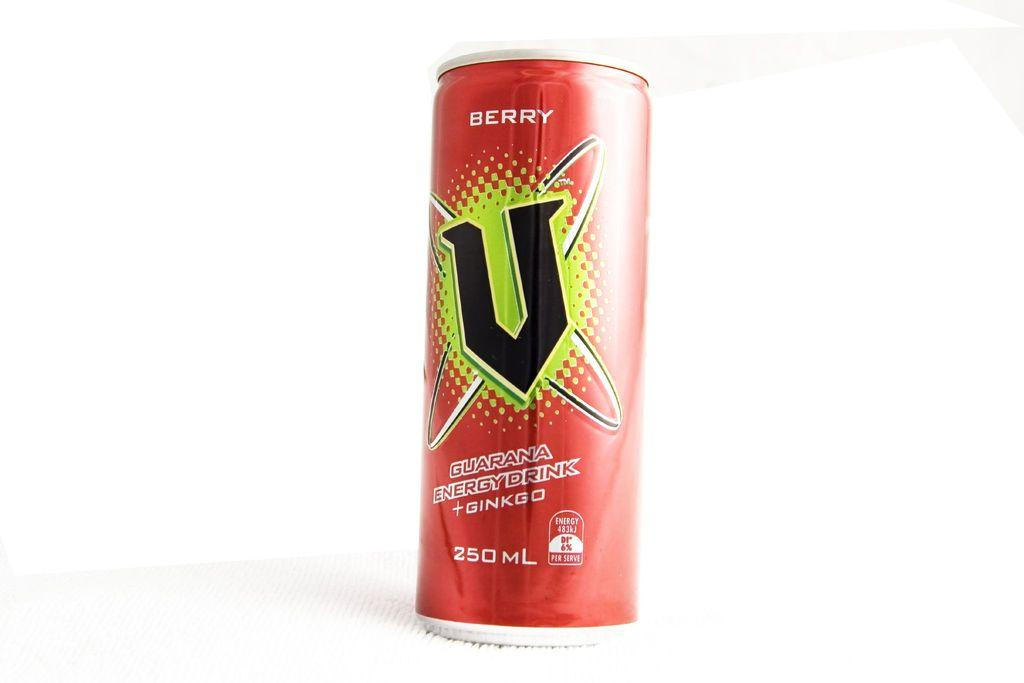What object is present in the image that has a specific color pattern? There is a tin in the image that has red, green, and black colors. What can be found on the surface of the tin? There is text written on the tin. What is the color of the background in the image? The background of the image is white. What type of humor can be found in the text written on the tin? There is no indication of humor in the text written on the tin, as the facts provided do not mention any humorous content. 